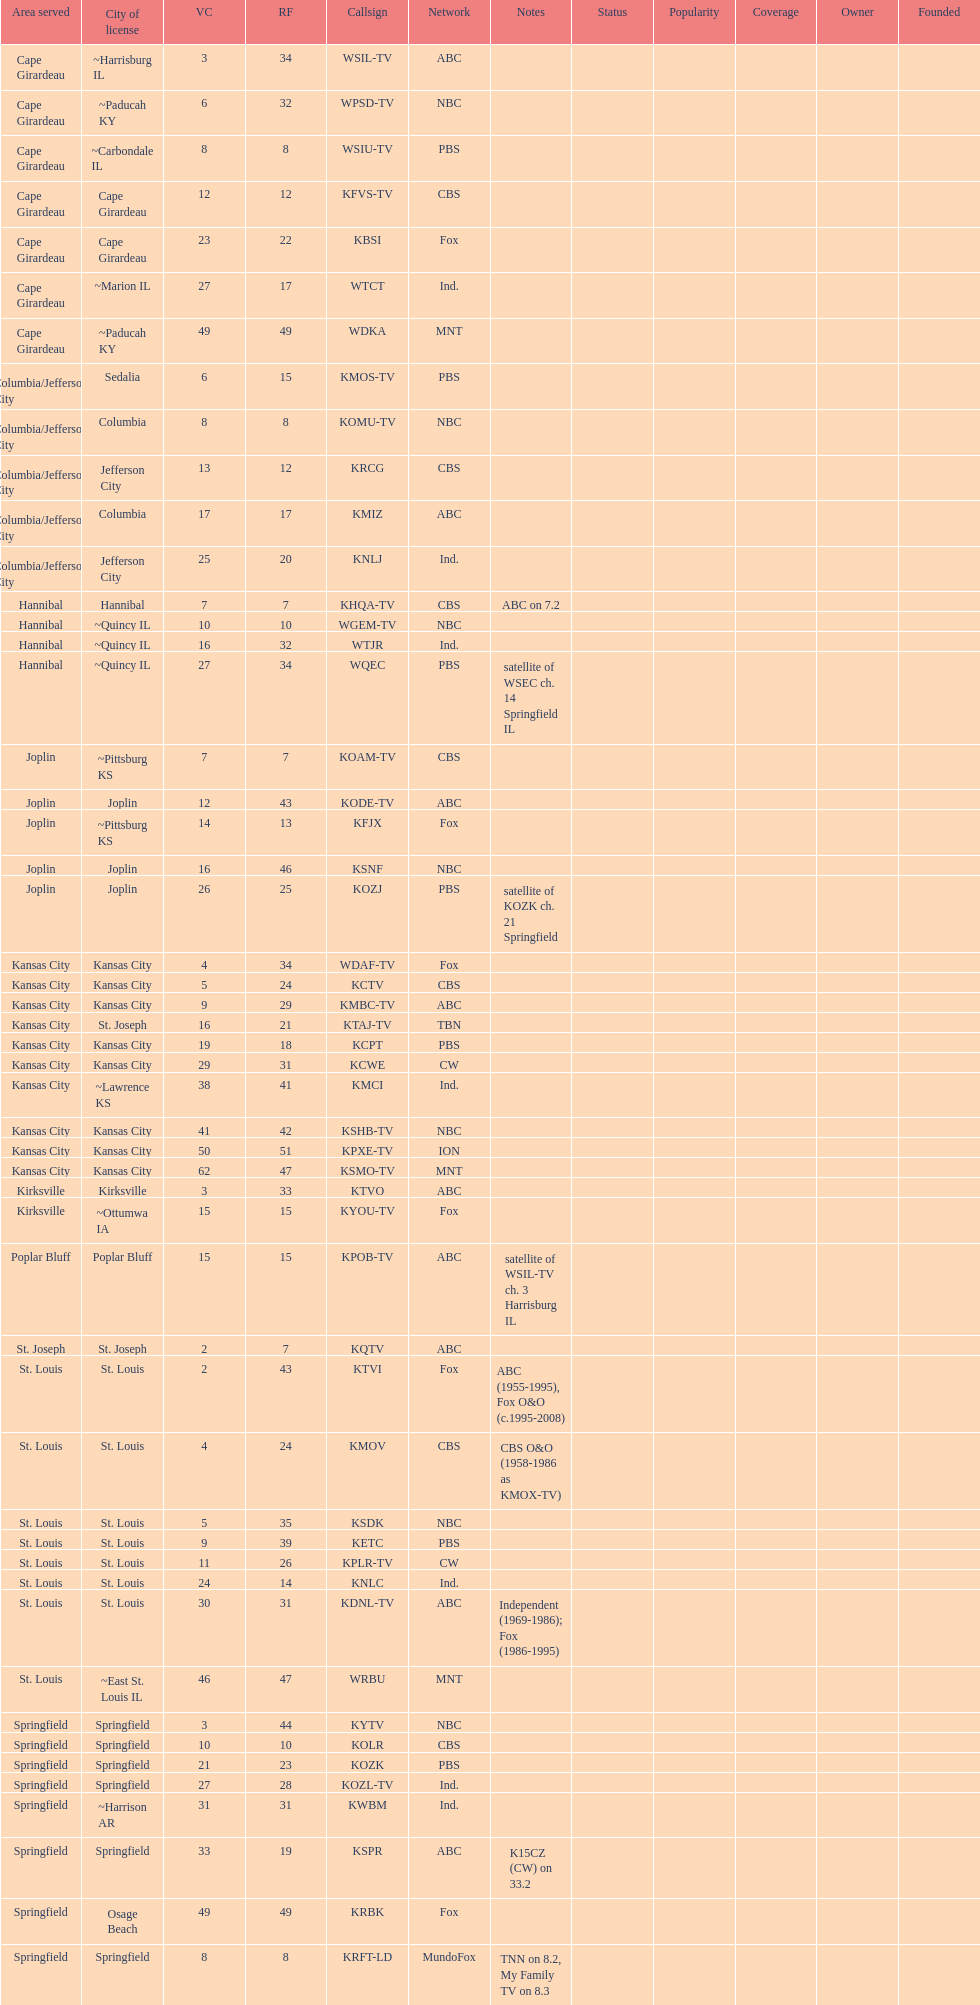How many television stations serve the cape girardeau area? 7. 